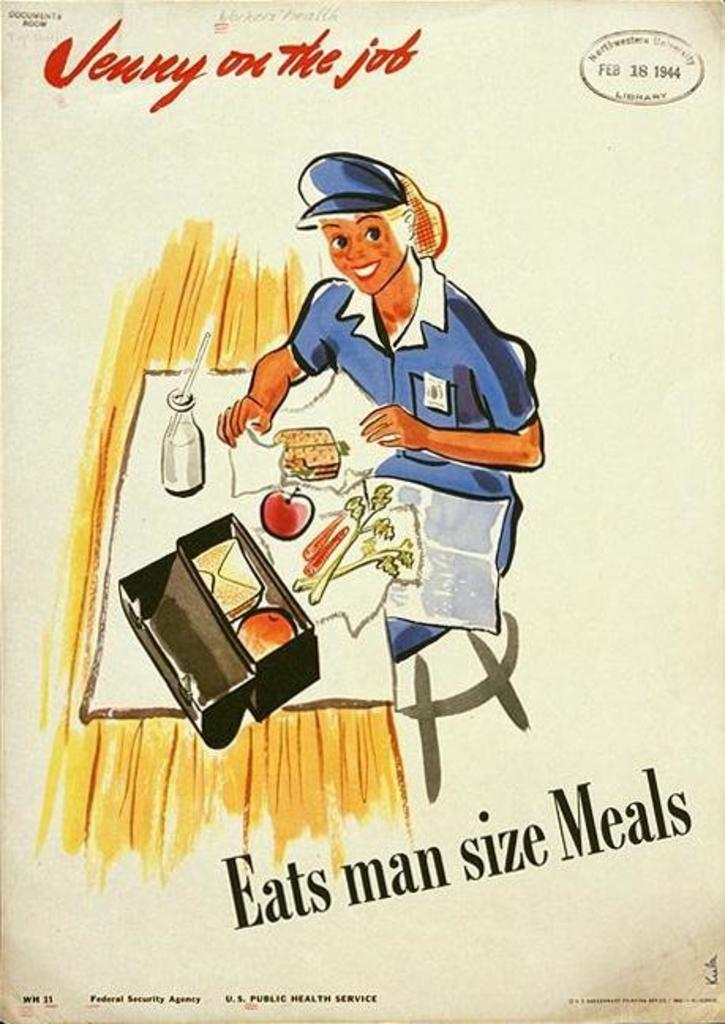<image>
Create a compact narrative representing the image presented. a poster from 1944 shows Jenny on the Job Eats man size Meals 